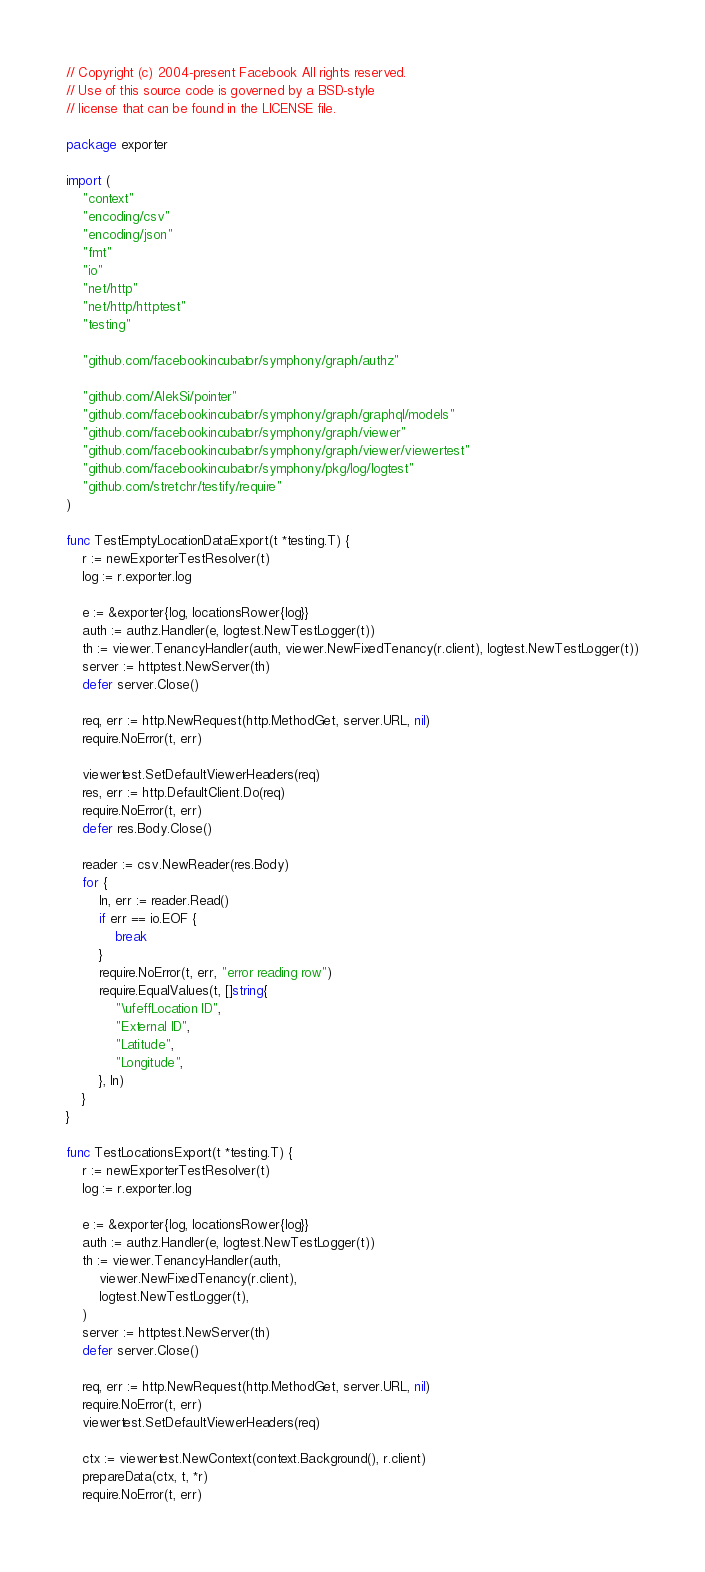<code> <loc_0><loc_0><loc_500><loc_500><_Go_>// Copyright (c) 2004-present Facebook All rights reserved.
// Use of this source code is governed by a BSD-style
// license that can be found in the LICENSE file.

package exporter

import (
	"context"
	"encoding/csv"
	"encoding/json"
	"fmt"
	"io"
	"net/http"
	"net/http/httptest"
	"testing"

	"github.com/facebookincubator/symphony/graph/authz"

	"github.com/AlekSi/pointer"
	"github.com/facebookincubator/symphony/graph/graphql/models"
	"github.com/facebookincubator/symphony/graph/viewer"
	"github.com/facebookincubator/symphony/graph/viewer/viewertest"
	"github.com/facebookincubator/symphony/pkg/log/logtest"
	"github.com/stretchr/testify/require"
)

func TestEmptyLocationDataExport(t *testing.T) {
	r := newExporterTestResolver(t)
	log := r.exporter.log

	e := &exporter{log, locationsRower{log}}
	auth := authz.Handler(e, logtest.NewTestLogger(t))
	th := viewer.TenancyHandler(auth, viewer.NewFixedTenancy(r.client), logtest.NewTestLogger(t))
	server := httptest.NewServer(th)
	defer server.Close()

	req, err := http.NewRequest(http.MethodGet, server.URL, nil)
	require.NoError(t, err)

	viewertest.SetDefaultViewerHeaders(req)
	res, err := http.DefaultClient.Do(req)
	require.NoError(t, err)
	defer res.Body.Close()

	reader := csv.NewReader(res.Body)
	for {
		ln, err := reader.Read()
		if err == io.EOF {
			break
		}
		require.NoError(t, err, "error reading row")
		require.EqualValues(t, []string{
			"\ufeffLocation ID",
			"External ID",
			"Latitude",
			"Longitude",
		}, ln)
	}
}

func TestLocationsExport(t *testing.T) {
	r := newExporterTestResolver(t)
	log := r.exporter.log

	e := &exporter{log, locationsRower{log}}
	auth := authz.Handler(e, logtest.NewTestLogger(t))
	th := viewer.TenancyHandler(auth,
		viewer.NewFixedTenancy(r.client),
		logtest.NewTestLogger(t),
	)
	server := httptest.NewServer(th)
	defer server.Close()

	req, err := http.NewRequest(http.MethodGet, server.URL, nil)
	require.NoError(t, err)
	viewertest.SetDefaultViewerHeaders(req)

	ctx := viewertest.NewContext(context.Background(), r.client)
	prepareData(ctx, t, *r)
	require.NoError(t, err)</code> 